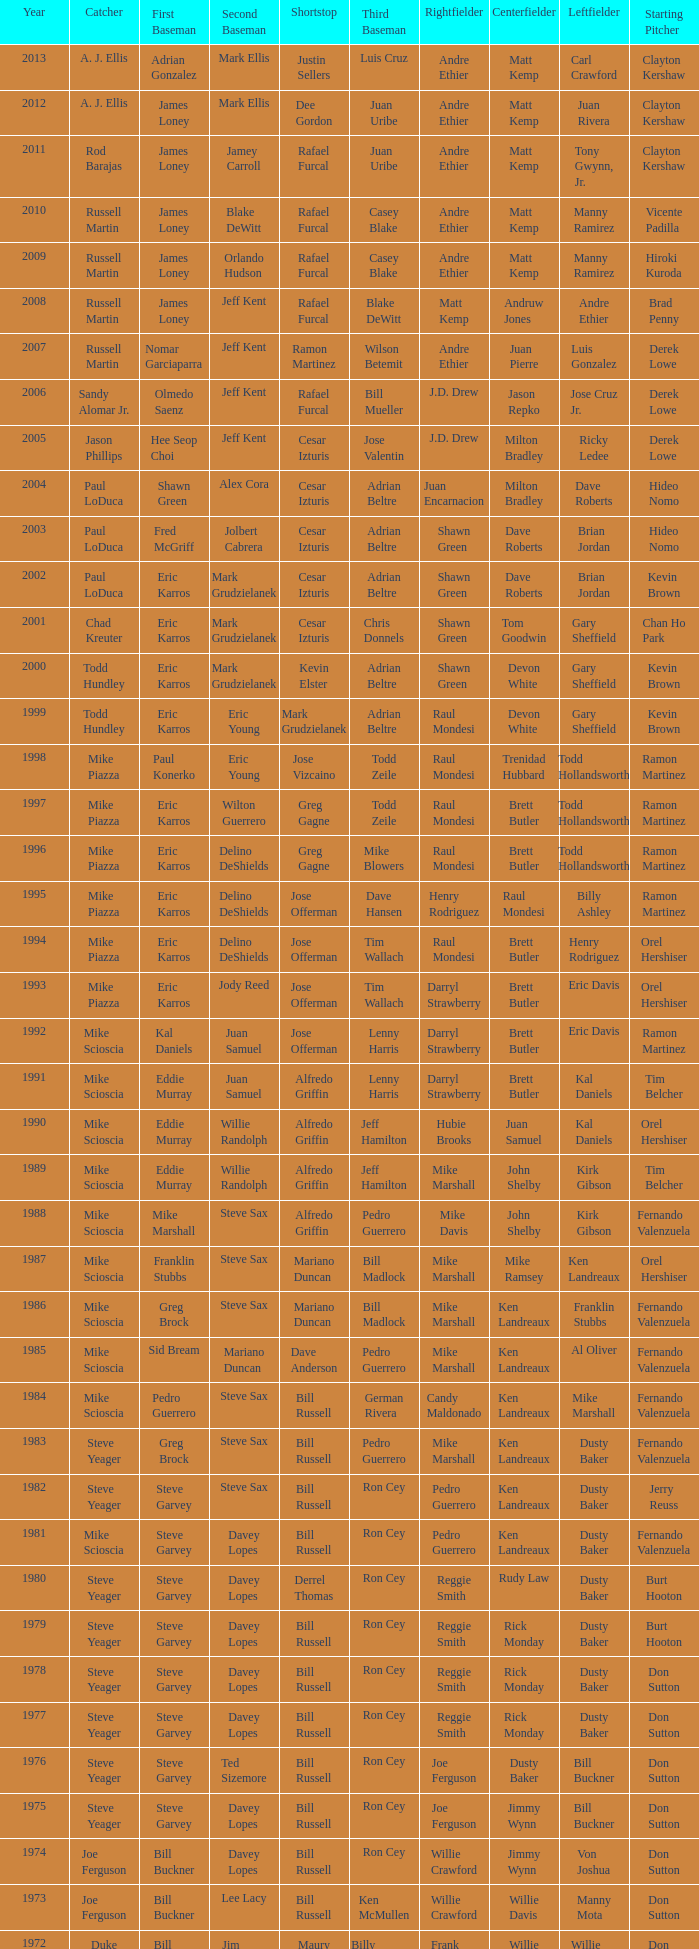Who was the ss when jim lefebvre played 2nd, willie davis occupied cf, and don drysdale took the sp position? Maury Wills. 